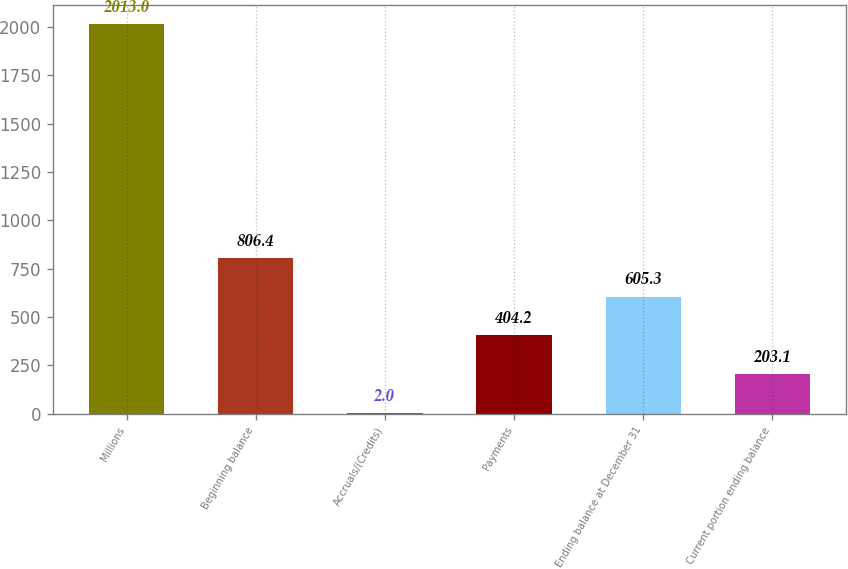Convert chart to OTSL. <chart><loc_0><loc_0><loc_500><loc_500><bar_chart><fcel>Millions<fcel>Beginning balance<fcel>Accruals/(Credits)<fcel>Payments<fcel>Ending balance at December 31<fcel>Current portion ending balance<nl><fcel>2013<fcel>806.4<fcel>2<fcel>404.2<fcel>605.3<fcel>203.1<nl></chart> 